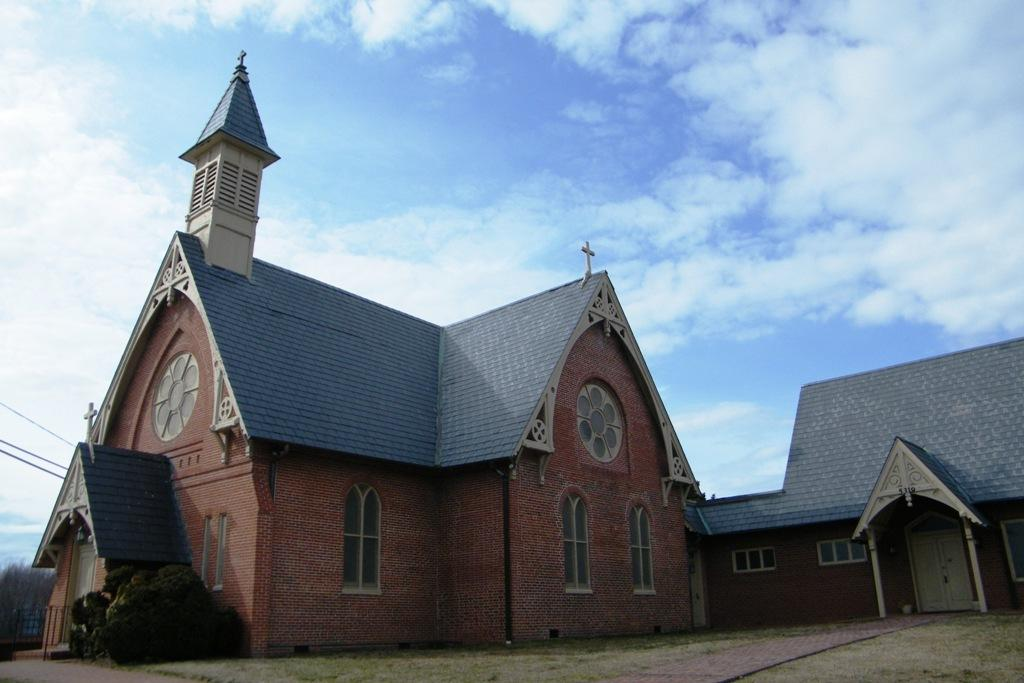What type of structure is present in the image? There is a castle in the image. What other elements can be seen in the image besides the castle? There are plants and wires in the image. What is visible in the background of the image? The sky is visible in the background of the image. Can you describe the sky in the image? There are clouds in the sky in the image. What type of wool is being used to construct the castle in the image? There is no wool present in the image, and the castle is not being constructed. 